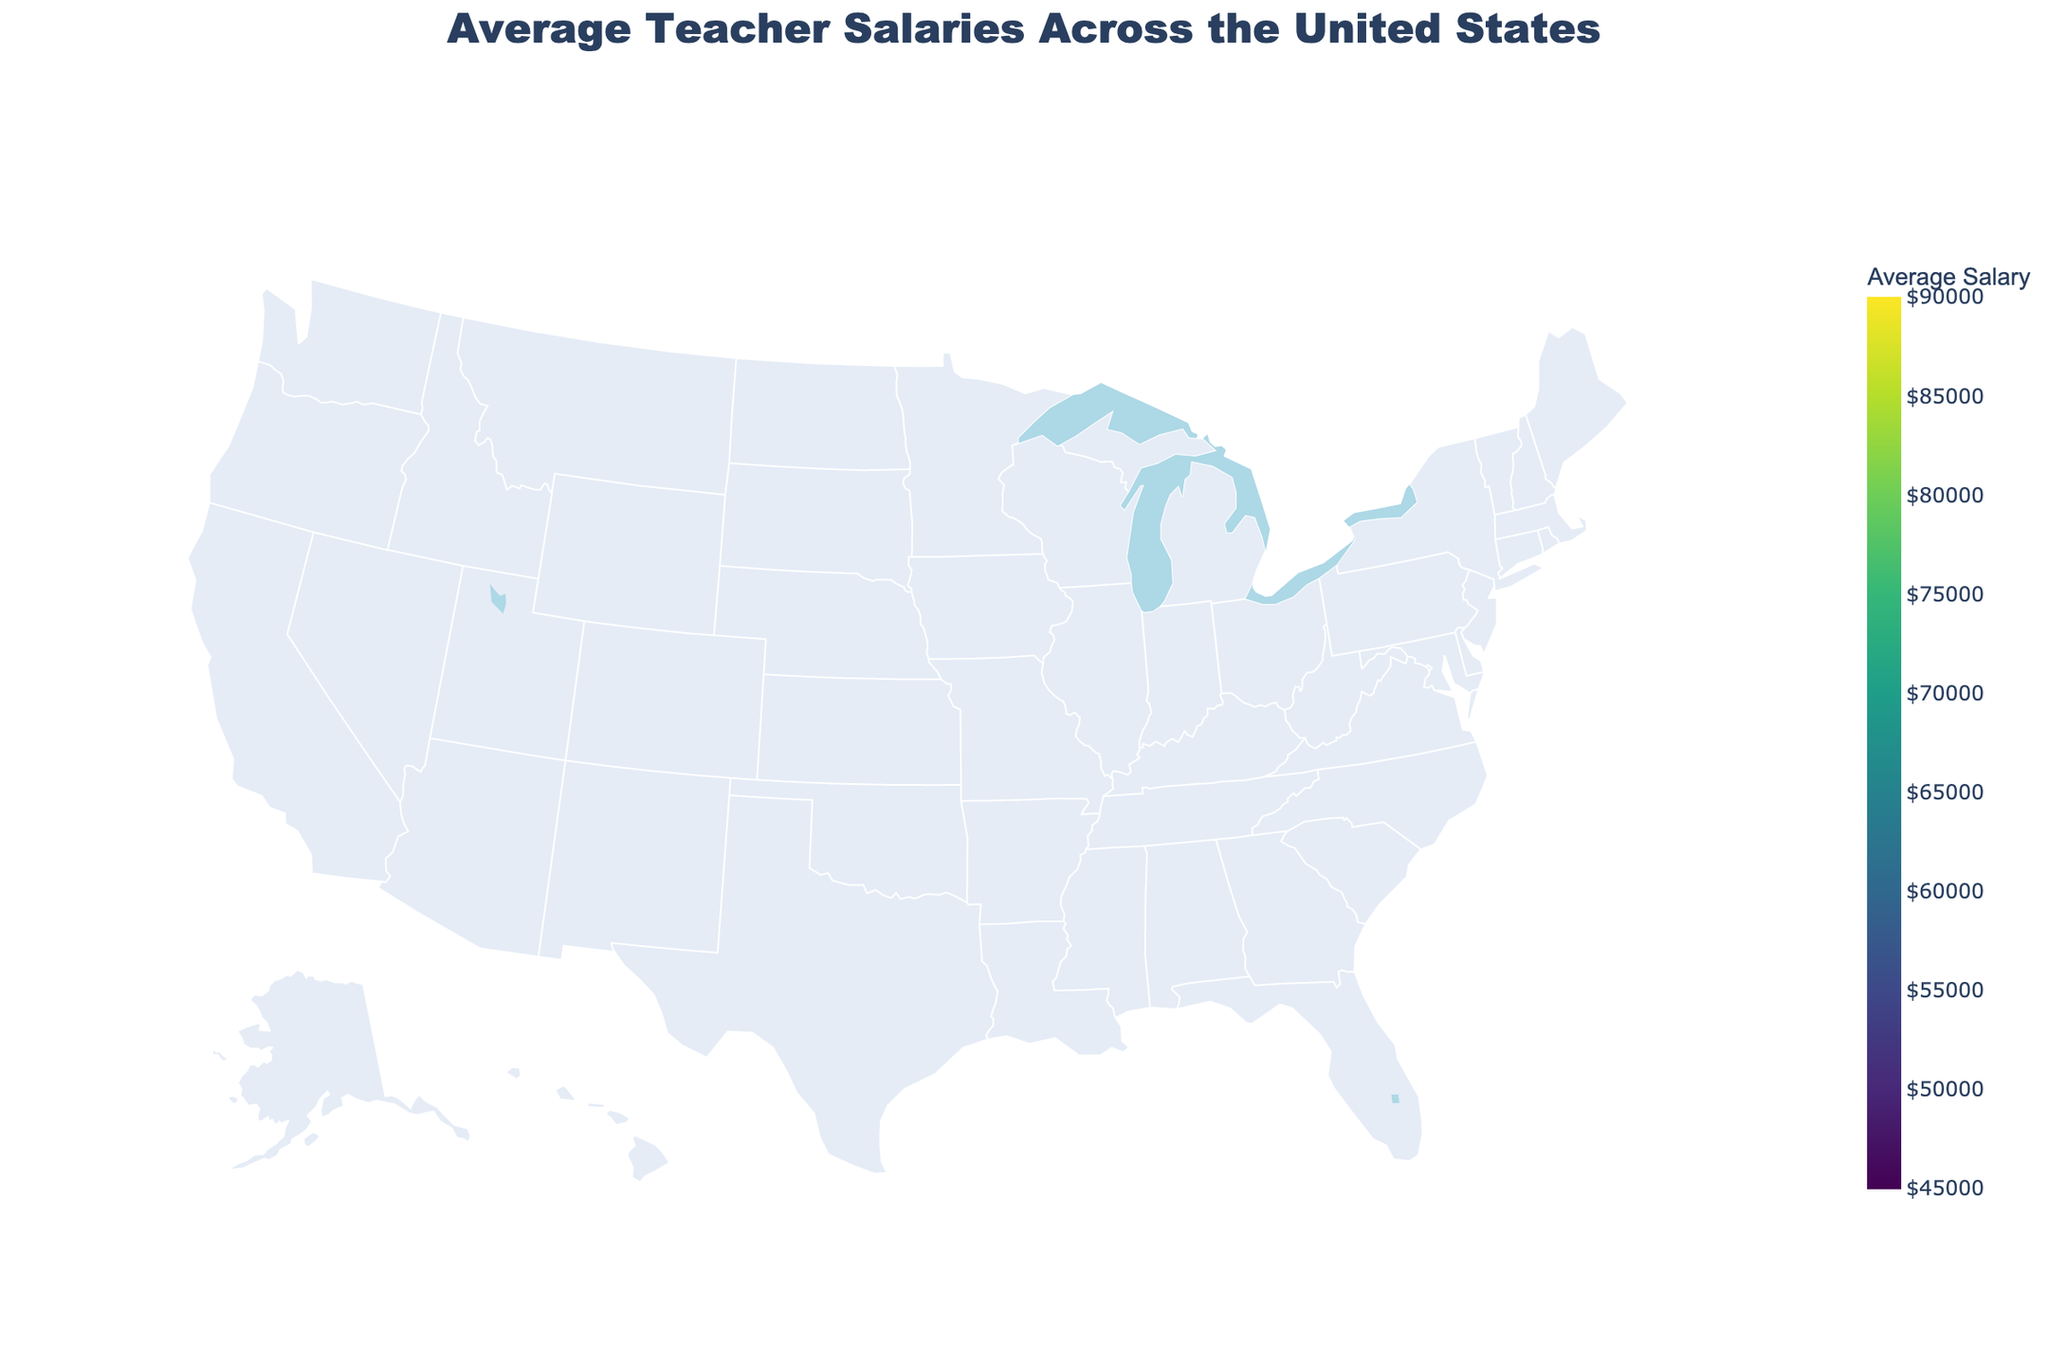What's the highest average teacher salary shown in the figure? The figure uses a color scale to represent average teacher salaries. The darkest color typically indicates the highest value. Referring to the figure, the state with the darkest color, New York, has the highest average teacher salary.
Answer: $85,889 Which state has the lowest average teacher salary? By observing the color scale and the regions with the lightest color, which typically indicates the lowest values, Mississippi is the state with the lowest average teacher salary shown on the map.
Answer: $45,574 Are there any states in the figure with average teacher salaries above $80,000? Yes, the darkest colors on the map correspond to states with the highest salaries. New York and California have average teacher salaries above $80,000.
Answer: Yes What's the difference between the highest and the lowest average teacher salaries? The highest average teacher salary is in New York ($85,889), and the lowest is in Mississippi ($45,574). The difference is $85,889 - $45,574.
Answer: $40,315 How many states have average teacher salaries in the $70,000 to $80,000 range? From the color scale and corresponding values, states in this range include Massachusetts, Connecticut, and New Jersey. Thus, there are three states in this range.
Answer: 3 Which states have average teacher salaries closest to $70,000? By examining the figure and the color scale, Maryland with $70,463 and Rhode Island with $69,995 have salaries closest to $70,000.
Answer: Maryland and Rhode Island Compare the average teacher salaries of the state with the highest salary and the state with the second highest salary. From the figure, New York has the highest salary at $85,889, and California has the second highest at $82,746. The difference is $85,889 - $82,746.
Answer: $3,143 What pattern do you observe about average teacher salaries in the northeastern states versus the southeastern states? The northeastern states like New York, Massachusetts, and Connecticut generally have higher average teacher salaries (darker colors) compared to southeastern states like Florida and North Carolina, which have lighter colors indicating lower salaries.
Answer: Northeastern states have higher salaries Which regions seem to have higher teacher salaries: the West Coast or the Midwest? By observing the color coding, the West Coast states like California and Washington have darker colors indicating higher salaries, while most Midwestern states like Ohio have lighter colors indicating lower salaries.
Answer: West Coast Does the figure show a clear regional difference in average teacher salaries? The figure shows that there are regional variations, with higher salaries in the Northeast and West Coast compared to the South and Midwest. This is evidenced by the varying colors on the map.
Answer: Yes 